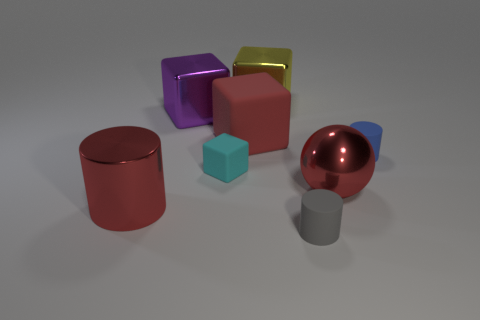Subtract all large cylinders. How many cylinders are left? 2 Subtract 1 blocks. How many blocks are left? 3 Add 1 purple cubes. How many objects exist? 9 Subtract all cyan cubes. How many cubes are left? 3 Subtract all brown blocks. Subtract all green cylinders. How many blocks are left? 4 Subtract all cylinders. How many objects are left? 5 Subtract all large yellow metallic objects. Subtract all small cylinders. How many objects are left? 5 Add 2 yellow cubes. How many yellow cubes are left? 3 Add 6 tiny blue objects. How many tiny blue objects exist? 7 Subtract 1 blue cylinders. How many objects are left? 7 